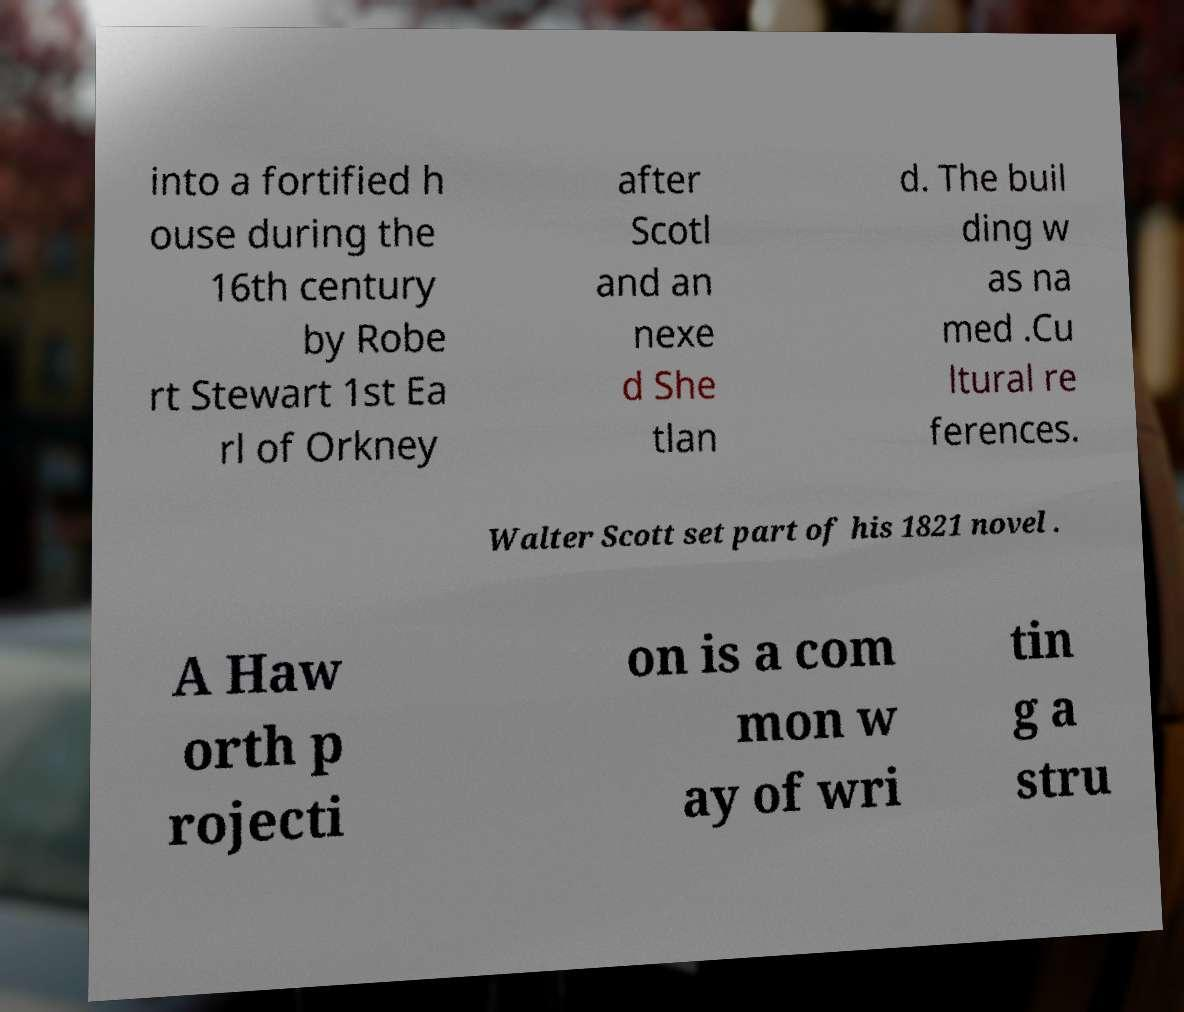Please identify and transcribe the text found in this image. into a fortified h ouse during the 16th century by Robe rt Stewart 1st Ea rl of Orkney after Scotl and an nexe d She tlan d. The buil ding w as na med .Cu ltural re ferences. Walter Scott set part of his 1821 novel . A Haw orth p rojecti on is a com mon w ay of wri tin g a stru 